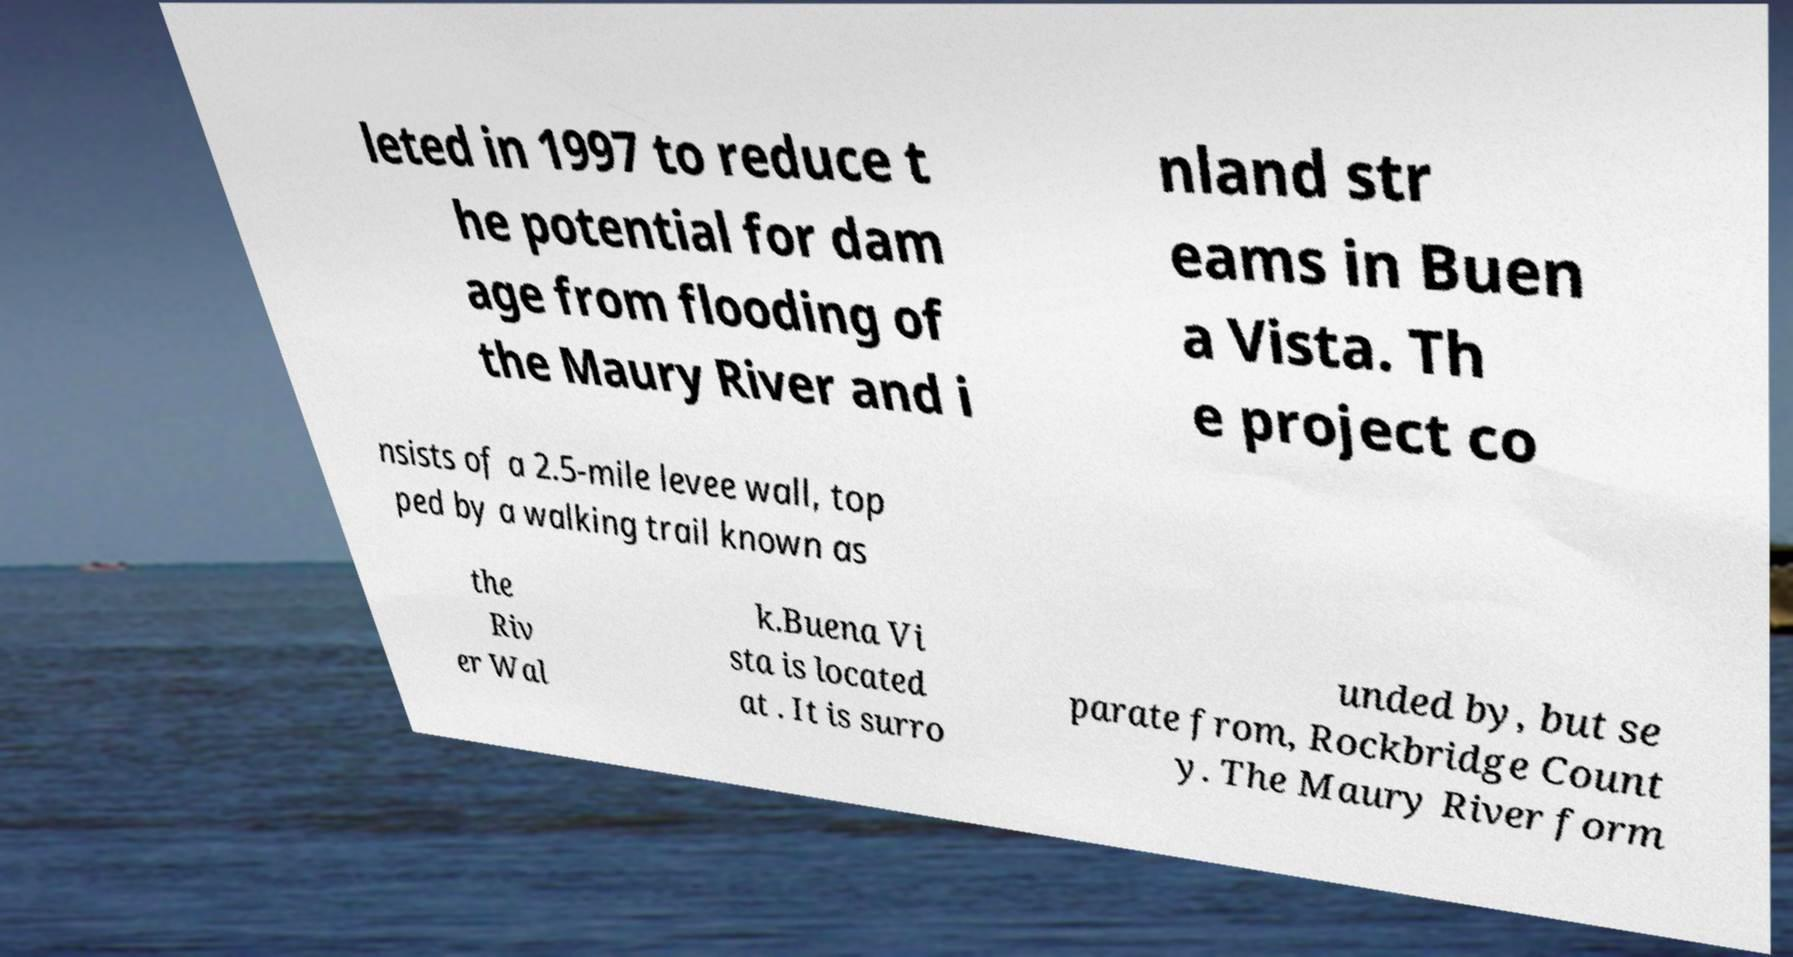Please identify and transcribe the text found in this image. leted in 1997 to reduce t he potential for dam age from flooding of the Maury River and i nland str eams in Buen a Vista. Th e project co nsists of a 2.5-mile levee wall, top ped by a walking trail known as the Riv er Wal k.Buena Vi sta is located at . It is surro unded by, but se parate from, Rockbridge Count y. The Maury River form 